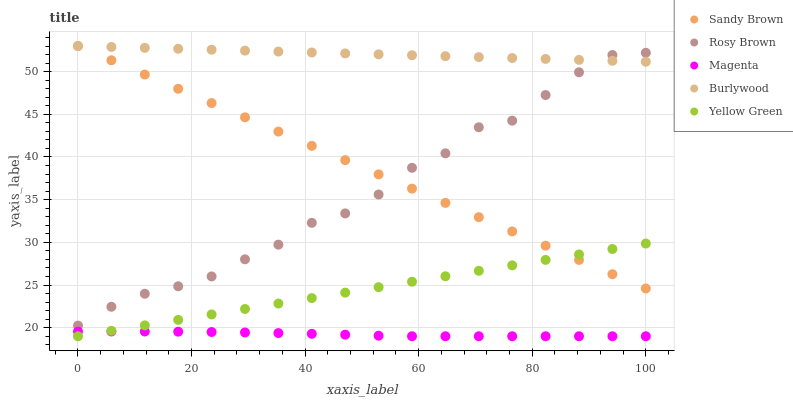Does Magenta have the minimum area under the curve?
Answer yes or no. Yes. Does Burlywood have the maximum area under the curve?
Answer yes or no. Yes. Does Rosy Brown have the minimum area under the curve?
Answer yes or no. No. Does Rosy Brown have the maximum area under the curve?
Answer yes or no. No. Is Burlywood the smoothest?
Answer yes or no. Yes. Is Rosy Brown the roughest?
Answer yes or no. Yes. Is Magenta the smoothest?
Answer yes or no. No. Is Magenta the roughest?
Answer yes or no. No. Does Magenta have the lowest value?
Answer yes or no. Yes. Does Rosy Brown have the lowest value?
Answer yes or no. No. Does Sandy Brown have the highest value?
Answer yes or no. Yes. Does Rosy Brown have the highest value?
Answer yes or no. No. Is Yellow Green less than Rosy Brown?
Answer yes or no. Yes. Is Rosy Brown greater than Magenta?
Answer yes or no. Yes. Does Yellow Green intersect Sandy Brown?
Answer yes or no. Yes. Is Yellow Green less than Sandy Brown?
Answer yes or no. No. Is Yellow Green greater than Sandy Brown?
Answer yes or no. No. Does Yellow Green intersect Rosy Brown?
Answer yes or no. No. 